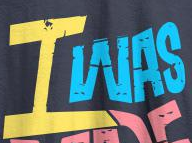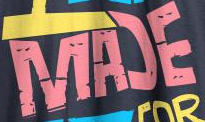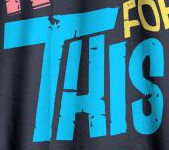Read the text from these images in sequence, separated by a semicolon. IWAS; MAƆE; THIS 